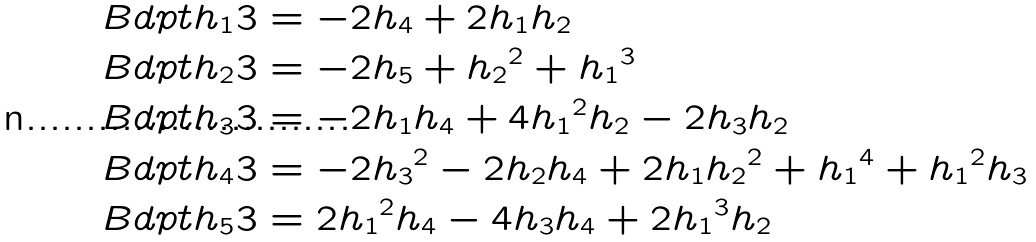<formula> <loc_0><loc_0><loc_500><loc_500>& \ B d p t { h _ { 1 } } 3 = - 2 h _ { 4 } + 2 h _ { 1 } h _ { 2 } \\ & \ B d p t { h _ { 2 } } 3 = - 2 h _ { 5 } + { h _ { 2 } } ^ { 2 } + { h _ { 1 } } ^ { 3 } \\ & \ B d p t { h _ { 3 } } 3 = - 2 h _ { 1 } h _ { 4 } + 4 { h _ { 1 } } ^ { 2 } h _ { 2 } - 2 h _ { 3 } h _ { 2 } \\ & \ B d p t { h _ { 4 } } 3 = - 2 { h _ { 3 } } ^ { 2 } - 2 h _ { 2 } h _ { 4 } + 2 h _ { 1 } { h _ { 2 } } ^ { 2 } + { h _ { 1 } } ^ { 4 } + { h _ { 1 } } ^ { 2 } h _ { 3 } \\ & \ B d p t { h _ { 5 } } 3 = 2 { h _ { 1 } } ^ { 2 } h _ { 4 } - 4 h _ { 3 } h _ { 4 } + 2 { h _ { 1 } } ^ { 3 } h _ { 2 } \\</formula> 